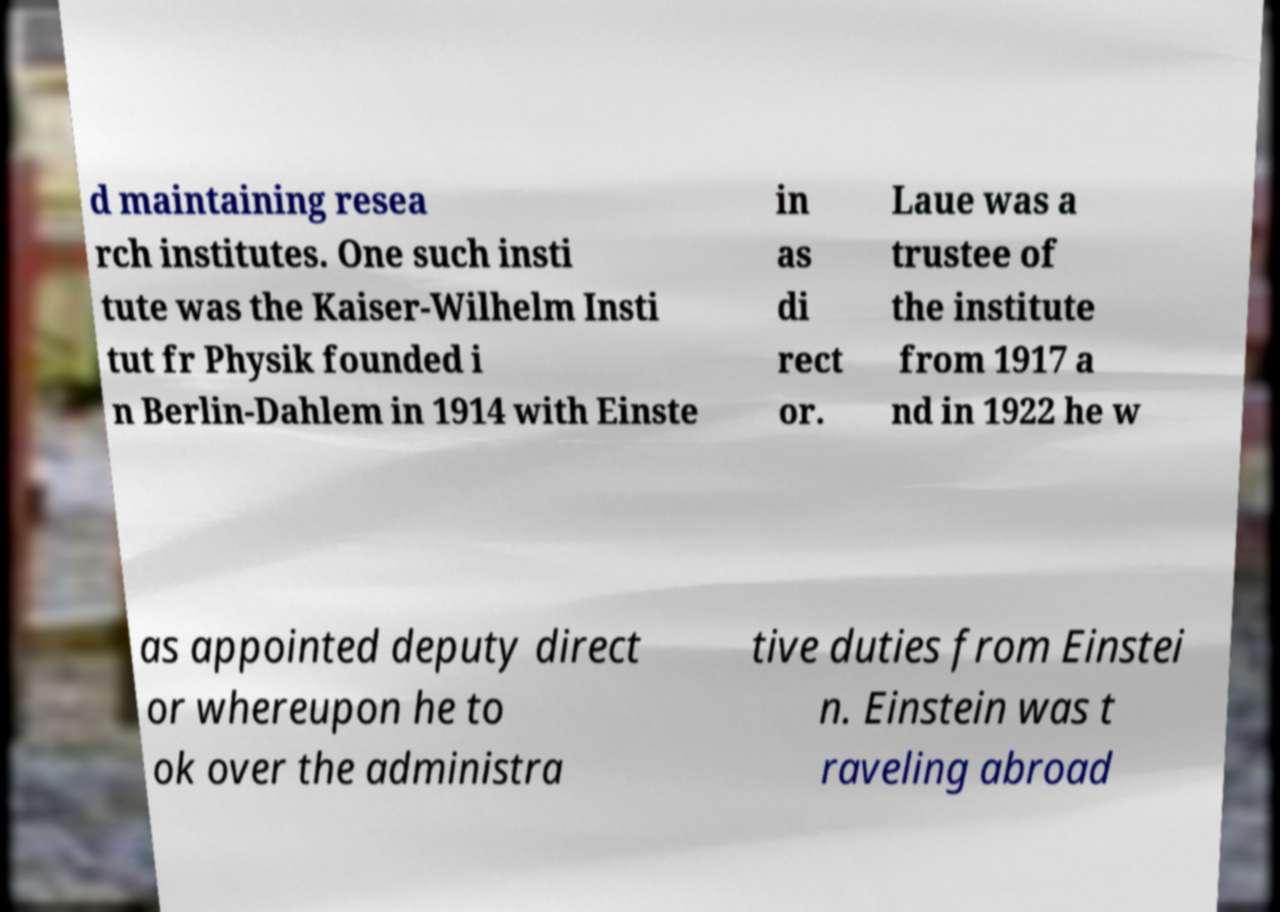Please identify and transcribe the text found in this image. d maintaining resea rch institutes. One such insti tute was the Kaiser-Wilhelm Insti tut fr Physik founded i n Berlin-Dahlem in 1914 with Einste in as di rect or. Laue was a trustee of the institute from 1917 a nd in 1922 he w as appointed deputy direct or whereupon he to ok over the administra tive duties from Einstei n. Einstein was t raveling abroad 